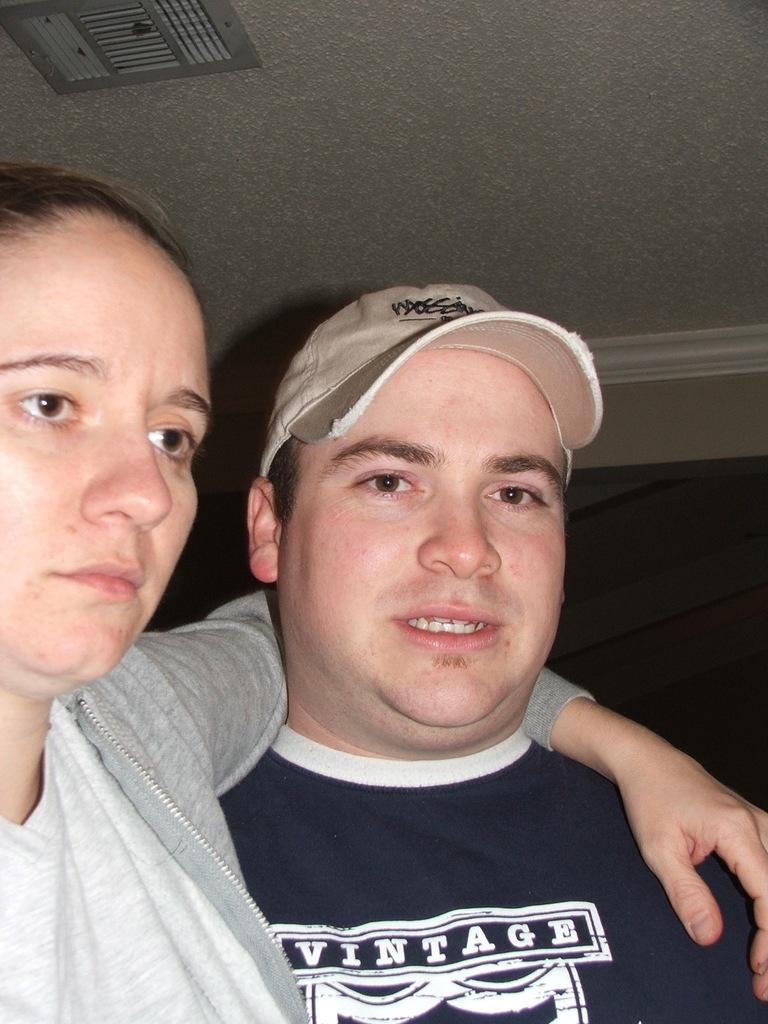<image>
Create a compact narrative representing the image presented. A man wears a shirt that says Vintage on the front. 